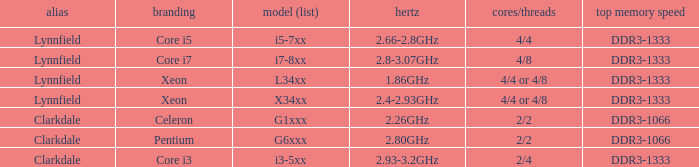What is the maximum memory speed for frequencies between 2.93-3.2ghz? DDR3-1333. 